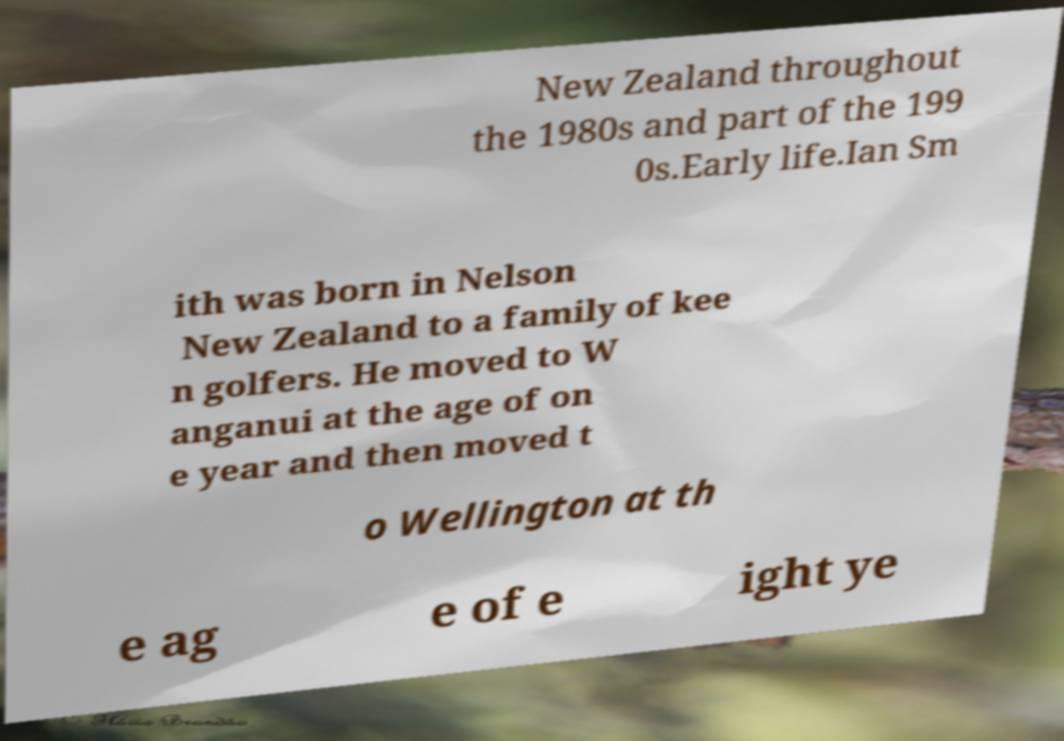Please read and relay the text visible in this image. What does it say? New Zealand throughout the 1980s and part of the 199 0s.Early life.Ian Sm ith was born in Nelson New Zealand to a family of kee n golfers. He moved to W anganui at the age of on e year and then moved t o Wellington at th e ag e of e ight ye 